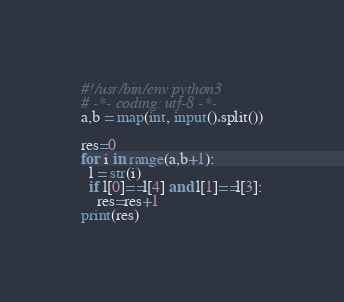Convert code to text. <code><loc_0><loc_0><loc_500><loc_500><_Python_>#!/usr/bin/env python3
# -*- coding: utf-8 -*-
a,b = map(int, input().split())

res=0
for i in range(a,b+1):
  l = str(i)
  if l[0]==l[4] and l[1]==l[3]:
    res=res+1
print(res)
</code> 